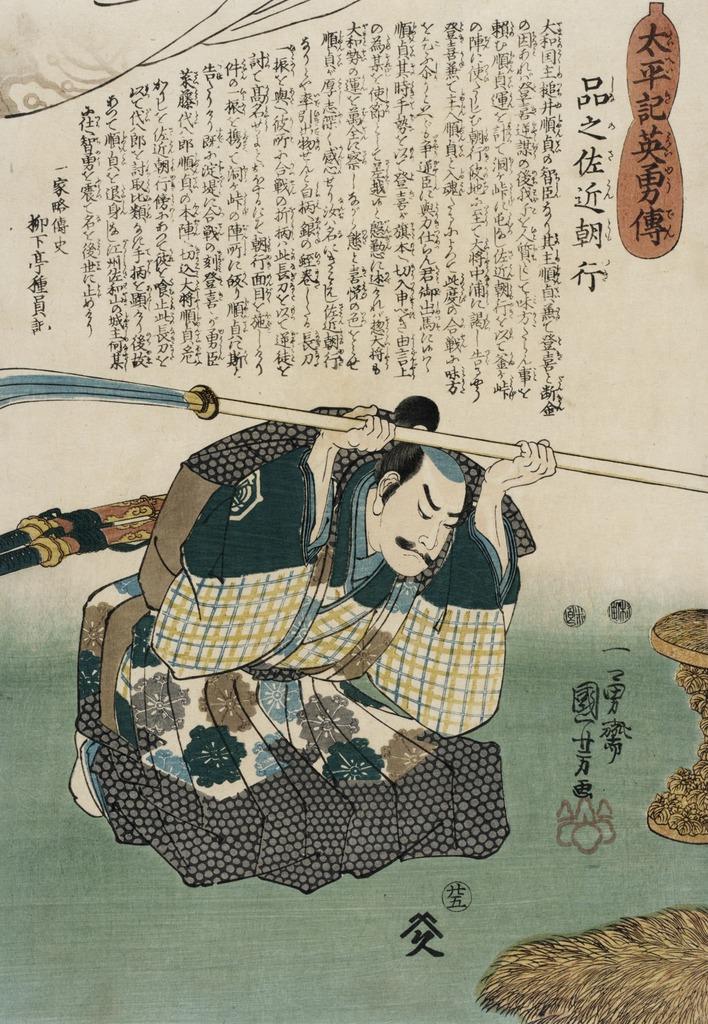Please provide a concise description of this image. There is a picture of a person on a paper as we can see in the middle of this image, and there is some text at the top of this image. 